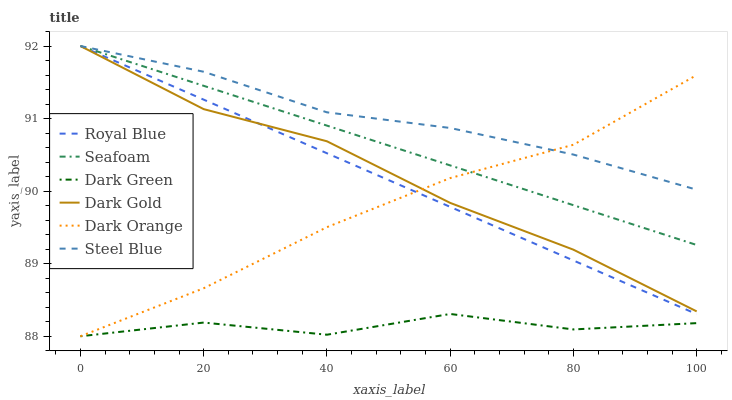Does Dark Green have the minimum area under the curve?
Answer yes or no. Yes. Does Steel Blue have the maximum area under the curve?
Answer yes or no. Yes. Does Dark Gold have the minimum area under the curve?
Answer yes or no. No. Does Dark Gold have the maximum area under the curve?
Answer yes or no. No. Is Royal Blue the smoothest?
Answer yes or no. Yes. Is Dark Green the roughest?
Answer yes or no. Yes. Is Dark Gold the smoothest?
Answer yes or no. No. Is Dark Gold the roughest?
Answer yes or no. No. Does Dark Orange have the lowest value?
Answer yes or no. Yes. Does Dark Gold have the lowest value?
Answer yes or no. No. Does Royal Blue have the highest value?
Answer yes or no. Yes. Does Dark Green have the highest value?
Answer yes or no. No. Is Dark Green less than Seafoam?
Answer yes or no. Yes. Is Dark Gold greater than Dark Green?
Answer yes or no. Yes. Does Steel Blue intersect Dark Gold?
Answer yes or no. Yes. Is Steel Blue less than Dark Gold?
Answer yes or no. No. Is Steel Blue greater than Dark Gold?
Answer yes or no. No. Does Dark Green intersect Seafoam?
Answer yes or no. No. 